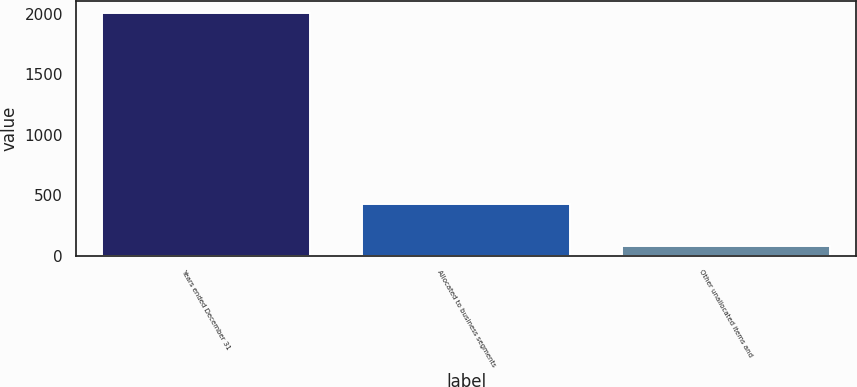<chart> <loc_0><loc_0><loc_500><loc_500><bar_chart><fcel>Years ended December 31<fcel>Allocated to business segments<fcel>Other unallocated items and<nl><fcel>2008<fcel>428<fcel>79<nl></chart> 